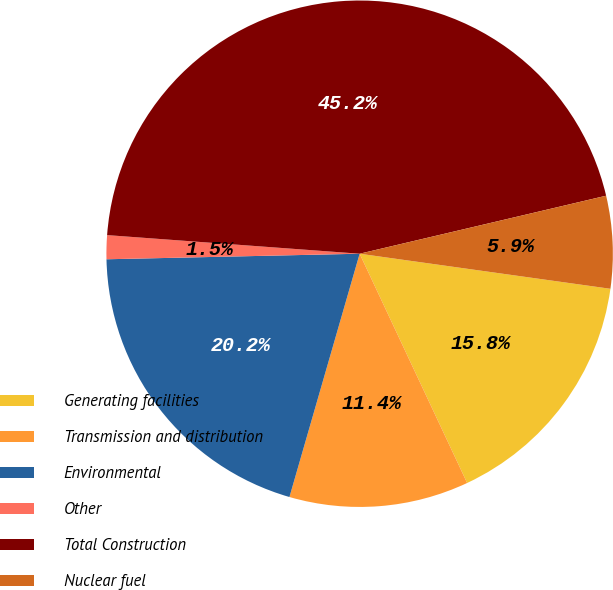<chart> <loc_0><loc_0><loc_500><loc_500><pie_chart><fcel>Generating facilities<fcel>Transmission and distribution<fcel>Environmental<fcel>Other<fcel>Total Construction<fcel>Nuclear fuel<nl><fcel>15.81%<fcel>11.45%<fcel>20.18%<fcel>1.52%<fcel>45.15%<fcel>5.89%<nl></chart> 